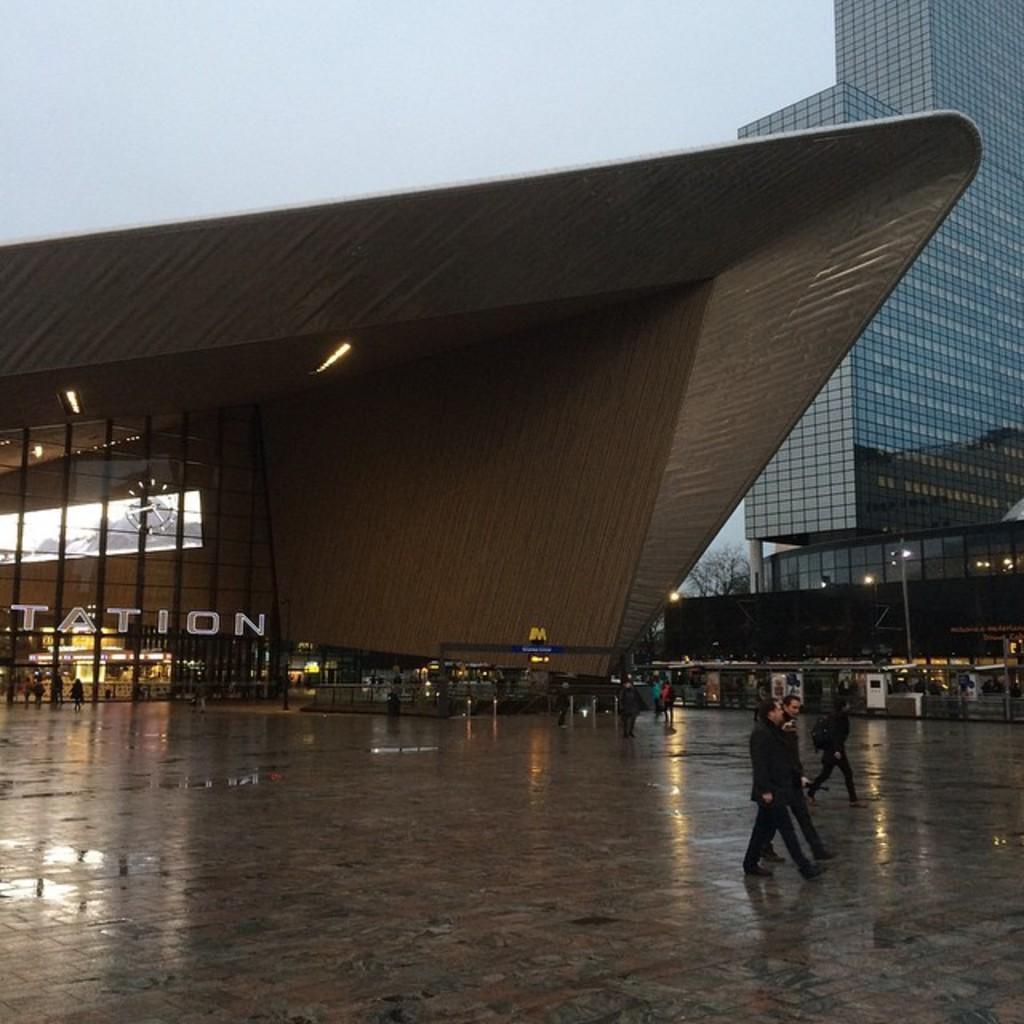Please provide a concise description of this image. In this image we can see people walking on the road also can see water. In the background, we can see different architecture building, we can see name board, clock, glass building, light poles and the sky. 